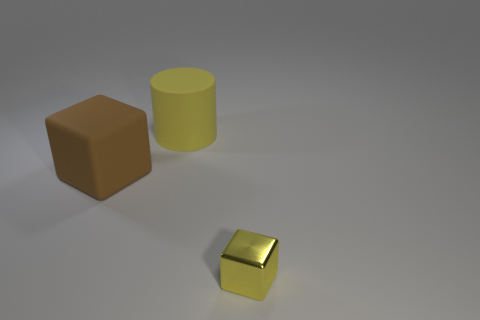Add 2 small brown blocks. How many objects exist? 5 Subtract all cylinders. How many objects are left? 2 Subtract 0 purple blocks. How many objects are left? 3 Subtract all rubber cylinders. Subtract all small yellow things. How many objects are left? 1 Add 2 tiny shiny objects. How many tiny shiny objects are left? 3 Add 2 small yellow things. How many small yellow things exist? 3 